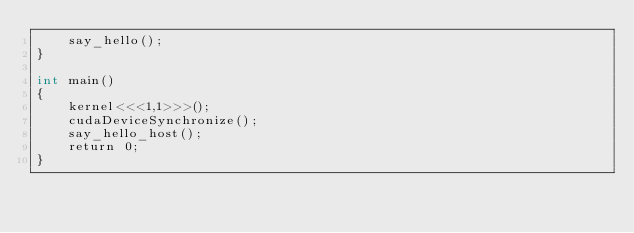Convert code to text. <code><loc_0><loc_0><loc_500><loc_500><_Cuda_>    say_hello();
}

int main()
{
    kernel<<<1,1>>>();
    cudaDeviceSynchronize();
    say_hello_host();
    return 0;
}</code> 